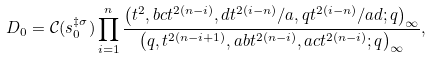<formula> <loc_0><loc_0><loc_500><loc_500>D _ { 0 } = \mathcal { C } ( s _ { 0 } ^ { \ddagger \sigma } ) \prod _ { i = 1 } ^ { n } \frac { \left ( t ^ { 2 } , b c t ^ { 2 ( n - i ) } , d t ^ { 2 ( i - n ) } / a , q t ^ { 2 ( i - n ) } / a d ; q \right ) _ { \infty } } { \left ( q , t ^ { 2 ( n - i + 1 ) } , a b t ^ { 2 ( n - i ) } , a c t ^ { 2 ( n - i ) } ; q \right ) _ { \infty } } ,</formula> 